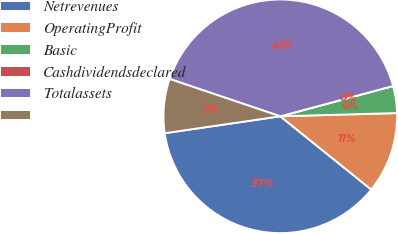<chart> <loc_0><loc_0><loc_500><loc_500><pie_chart><fcel>Netrevenues<fcel>OperatingProfit<fcel>Basic<fcel>Cashdividendsdeclared<fcel>Totalassets<fcel>Unnamed: 5<nl><fcel>36.9%<fcel>11.23%<fcel>3.74%<fcel>0.0%<fcel>40.64%<fcel>7.49%<nl></chart> 